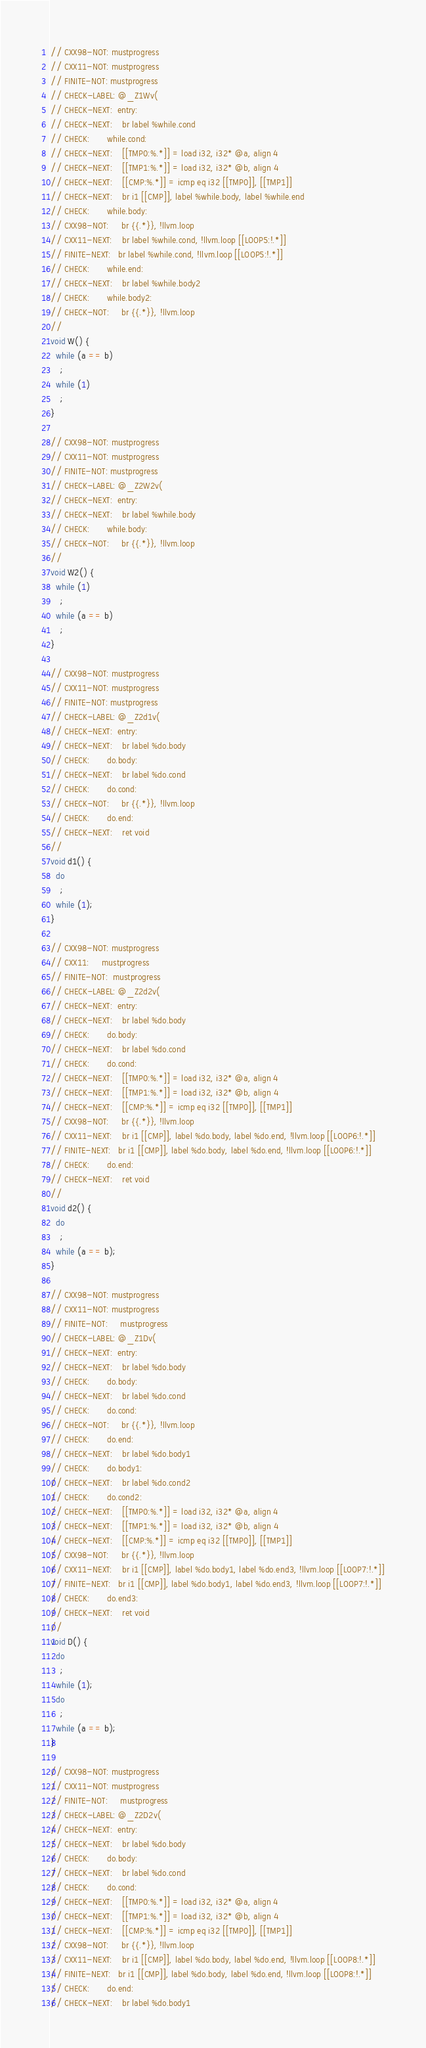Convert code to text. <code><loc_0><loc_0><loc_500><loc_500><_C++_>
// CXX98-NOT: mustprogress
// CXX11-NOT: mustprogress
// FINITE-NOT: mustprogress
// CHECK-LABEL: @_Z1Wv(
// CHECK-NEXT:  entry:
// CHECK-NEXT:    br label %while.cond
// CHECK:       while.cond:
// CHECK-NEXT:    [[TMP0:%.*]] = load i32, i32* @a, align 4
// CHECK-NEXT:    [[TMP1:%.*]] = load i32, i32* @b, align 4
// CHECK-NEXT:    [[CMP:%.*]] = icmp eq i32 [[TMP0]], [[TMP1]]
// CHECK-NEXT:    br i1 [[CMP]], label %while.body, label %while.end
// CHECK:       while.body:
// CXX98-NOT:     br {{.*}}, !llvm.loop
// CXX11-NEXT:    br label %while.cond, !llvm.loop [[LOOP5:!.*]]
// FINITE-NEXT:   br label %while.cond, !llvm.loop [[LOOP5:!.*]]
// CHECK:       while.end:
// CHECK-NEXT:    br label %while.body2
// CHECK:       while.body2:
// CHECK-NOT:     br {{.*}}, !llvm.loop
//
void W() {
  while (a == b)
    ;
  while (1)
    ;
}

// CXX98-NOT: mustprogress
// CXX11-NOT: mustprogress
// FINITE-NOT: mustprogress
// CHECK-LABEL: @_Z2W2v(
// CHECK-NEXT:  entry:
// CHECK-NEXT:    br label %while.body
// CHECK:       while.body:
// CHECK-NOT:     br {{.*}}, !llvm.loop
//
void W2() {
  while (1)
    ;
  while (a == b)
    ;
}

// CXX98-NOT: mustprogress
// CXX11-NOT: mustprogress
// FINITE-NOT: mustprogress
// CHECK-LABEL: @_Z2d1v(
// CHECK-NEXT:  entry:
// CHECK-NEXT:    br label %do.body
// CHECK:       do.body:
// CHECK-NEXT:    br label %do.cond
// CHECK:       do.cond:
// CHECK-NOT:     br {{.*}}, !llvm.loop
// CHECK:       do.end:
// CHECK-NEXT:    ret void
//
void d1() {
  do
    ;
  while (1);
}

// CXX98-NOT: mustprogress
// CXX11:     mustprogress
// FINITE-NOT:  mustprogress
// CHECK-LABEL: @_Z2d2v(
// CHECK-NEXT:  entry:
// CHECK-NEXT:    br label %do.body
// CHECK:       do.body:
// CHECK-NEXT:    br label %do.cond
// CHECK:       do.cond:
// CHECK-NEXT:    [[TMP0:%.*]] = load i32, i32* @a, align 4
// CHECK-NEXT:    [[TMP1:%.*]] = load i32, i32* @b, align 4
// CHECK-NEXT:    [[CMP:%.*]] = icmp eq i32 [[TMP0]], [[TMP1]]
// CXX98-NOT:     br {{.*}}, !llvm.loop
// CXX11-NEXT:    br i1 [[CMP]], label %do.body, label %do.end, !llvm.loop [[LOOP6:!.*]]
// FINITE-NEXT:   br i1 [[CMP]], label %do.body, label %do.end, !llvm.loop [[LOOP6:!.*]]
// CHECK:       do.end:
// CHECK-NEXT:    ret void
//
void d2() {
  do
    ;
  while (a == b);
}

// CXX98-NOT: mustprogress
// CXX11-NOT: mustprogress
// FINITE-NOT:     mustprogress
// CHECK-LABEL: @_Z1Dv(
// CHECK-NEXT:  entry:
// CHECK-NEXT:    br label %do.body
// CHECK:       do.body:
// CHECK-NEXT:    br label %do.cond
// CHECK:       do.cond:
// CHECK-NOT:     br {{.*}}, !llvm.loop
// CHECK:       do.end:
// CHECK-NEXT:    br label %do.body1
// CHECK:       do.body1:
// CHECK-NEXT:    br label %do.cond2
// CHECK:       do.cond2:
// CHECK-NEXT:    [[TMP0:%.*]] = load i32, i32* @a, align 4
// CHECK-NEXT:    [[TMP1:%.*]] = load i32, i32* @b, align 4
// CHECK-NEXT:    [[CMP:%.*]] = icmp eq i32 [[TMP0]], [[TMP1]]
// CXX98-NOT:     br {{.*}}, !llvm.loop
// CXX11-NEXT:    br i1 [[CMP]], label %do.body1, label %do.end3, !llvm.loop [[LOOP7:!.*]]
// FINITE-NEXT:   br i1 [[CMP]], label %do.body1, label %do.end3, !llvm.loop [[LOOP7:!.*]]
// CHECK:       do.end3:
// CHECK-NEXT:    ret void
//
void D() {
  do
    ;
  while (1);
  do
    ;
  while (a == b);
}

// CXX98-NOT: mustprogress
// CXX11-NOT: mustprogress
// FINITE-NOT:     mustprogress
// CHECK-LABEL: @_Z2D2v(
// CHECK-NEXT:  entry:
// CHECK-NEXT:    br label %do.body
// CHECK:       do.body:
// CHECK-NEXT:    br label %do.cond
// CHECK:       do.cond:
// CHECK-NEXT:    [[TMP0:%.*]] = load i32, i32* @a, align 4
// CHECK-NEXT:    [[TMP1:%.*]] = load i32, i32* @b, align 4
// CHECK-NEXT:    [[CMP:%.*]] = icmp eq i32 [[TMP0]], [[TMP1]]
// CXX98-NOT:     br {{.*}}, !llvm.loop
// CXX11-NEXT:    br i1 [[CMP]], label %do.body, label %do.end, !llvm.loop [[LOOP8:!.*]]
// FINITE-NEXT:   br i1 [[CMP]], label %do.body, label %do.end, !llvm.loop [[LOOP8:!.*]]
// CHECK:       do.end:
// CHECK-NEXT:    br label %do.body1</code> 